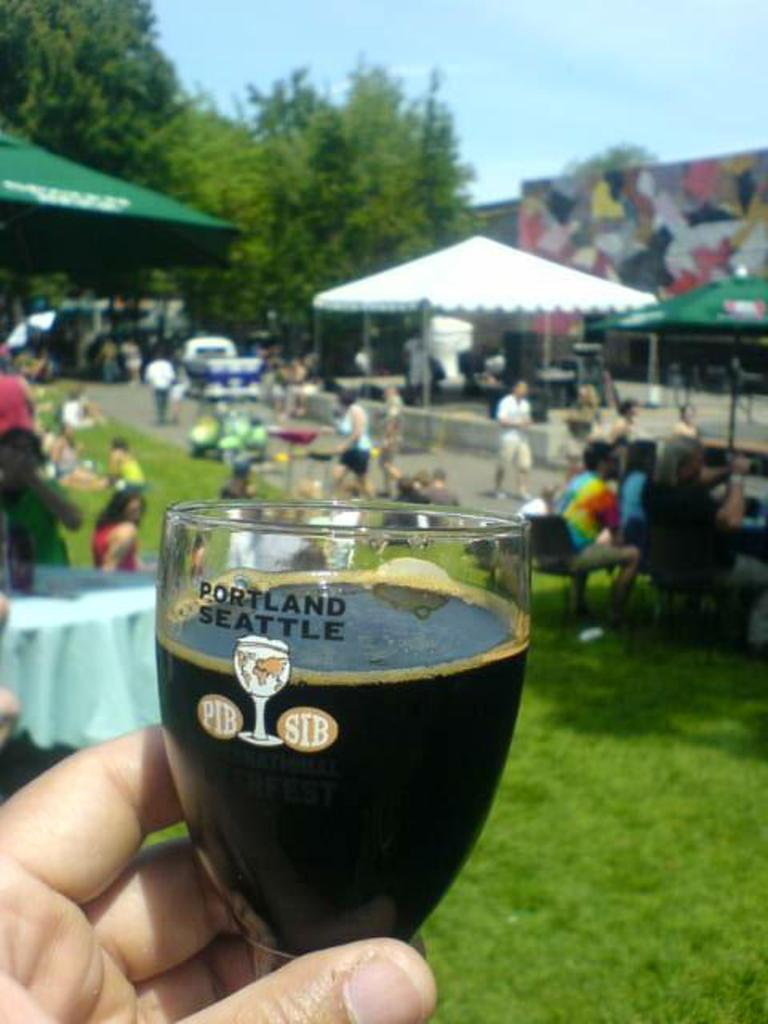<image>
Give a short and clear explanation of the subsequent image. a man holding a glass that says PORTLAND SEATTLE with liquor in it and people having a fun time in the background. 